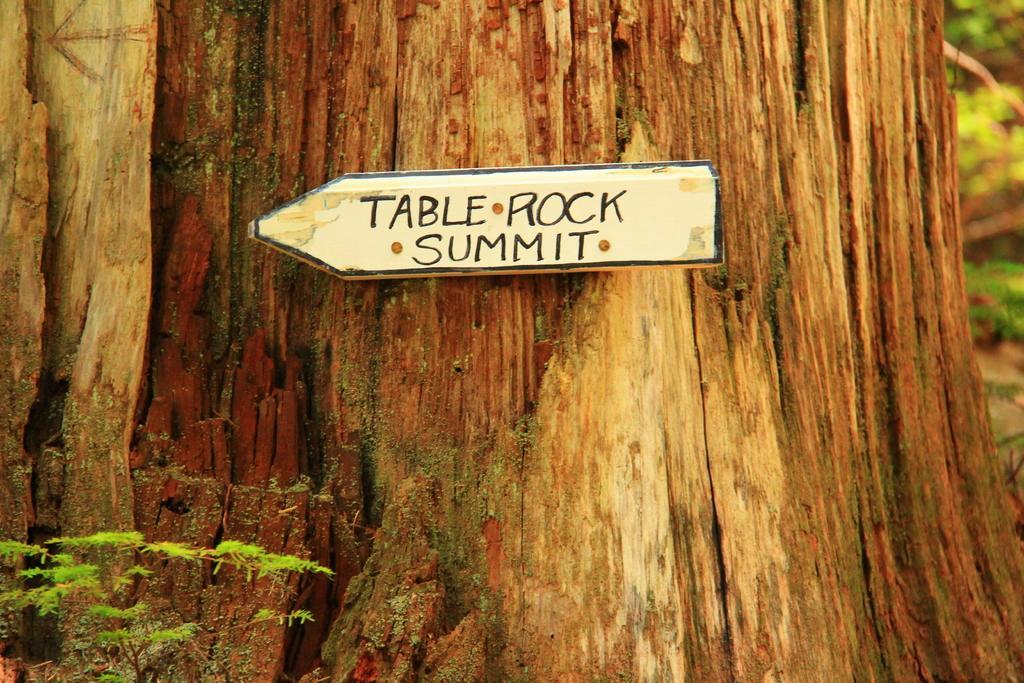In one or two sentences, can you explain what this image depicts? In this image in the center there are trees and on the trees there is a board, on the board there is text and at the bottom there are some plants and in the background also there are plants. 